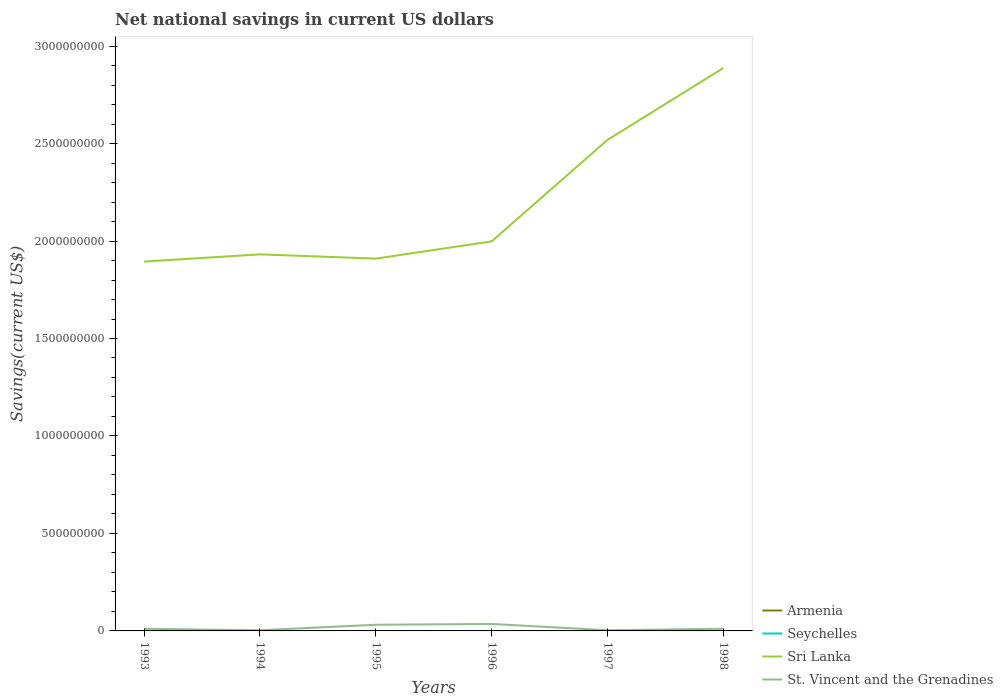What is the total net national savings in St. Vincent and the Grenadines in the graph?
Your answer should be very brief. -7.88e+06. What is the difference between the highest and the second highest net national savings in St. Vincent and the Grenadines?
Your response must be concise. 3.24e+07. Is the net national savings in Seychelles strictly greater than the net national savings in St. Vincent and the Grenadines over the years?
Your response must be concise. Yes. How many lines are there?
Your answer should be compact. 2. How many years are there in the graph?
Keep it short and to the point. 6. Does the graph contain any zero values?
Your answer should be compact. Yes. Does the graph contain grids?
Give a very brief answer. No. Where does the legend appear in the graph?
Provide a short and direct response. Bottom right. How are the legend labels stacked?
Offer a very short reply. Vertical. What is the title of the graph?
Provide a short and direct response. Net national savings in current US dollars. Does "St. Lucia" appear as one of the legend labels in the graph?
Give a very brief answer. No. What is the label or title of the Y-axis?
Your answer should be compact. Savings(current US$). What is the Savings(current US$) in Armenia in 1993?
Keep it short and to the point. 0. What is the Savings(current US$) in Sri Lanka in 1993?
Make the answer very short. 1.89e+09. What is the Savings(current US$) of St. Vincent and the Grenadines in 1993?
Make the answer very short. 1.11e+07. What is the Savings(current US$) in Sri Lanka in 1994?
Make the answer very short. 1.93e+09. What is the Savings(current US$) in St. Vincent and the Grenadines in 1994?
Ensure brevity in your answer.  3.37e+06. What is the Savings(current US$) in Sri Lanka in 1995?
Provide a succinct answer. 1.91e+09. What is the Savings(current US$) in St. Vincent and the Grenadines in 1995?
Provide a succinct answer. 3.17e+07. What is the Savings(current US$) in Seychelles in 1996?
Keep it short and to the point. 0. What is the Savings(current US$) of Sri Lanka in 1996?
Your response must be concise. 2.00e+09. What is the Savings(current US$) in St. Vincent and the Grenadines in 1996?
Provide a short and direct response. 3.58e+07. What is the Savings(current US$) in Sri Lanka in 1997?
Offer a terse response. 2.52e+09. What is the Savings(current US$) of St. Vincent and the Grenadines in 1997?
Your answer should be very brief. 3.52e+06. What is the Savings(current US$) in Seychelles in 1998?
Your answer should be very brief. 0. What is the Savings(current US$) in Sri Lanka in 1998?
Your response must be concise. 2.89e+09. What is the Savings(current US$) of St. Vincent and the Grenadines in 1998?
Make the answer very short. 1.14e+07. Across all years, what is the maximum Savings(current US$) of Sri Lanka?
Your answer should be very brief. 2.89e+09. Across all years, what is the maximum Savings(current US$) in St. Vincent and the Grenadines?
Provide a succinct answer. 3.58e+07. Across all years, what is the minimum Savings(current US$) in Sri Lanka?
Provide a succinct answer. 1.89e+09. Across all years, what is the minimum Savings(current US$) in St. Vincent and the Grenadines?
Give a very brief answer. 3.37e+06. What is the total Savings(current US$) in Sri Lanka in the graph?
Your response must be concise. 1.31e+1. What is the total Savings(current US$) in St. Vincent and the Grenadines in the graph?
Offer a terse response. 9.69e+07. What is the difference between the Savings(current US$) in Sri Lanka in 1993 and that in 1994?
Make the answer very short. -3.71e+07. What is the difference between the Savings(current US$) of St. Vincent and the Grenadines in 1993 and that in 1994?
Offer a terse response. 7.76e+06. What is the difference between the Savings(current US$) in Sri Lanka in 1993 and that in 1995?
Give a very brief answer. -1.53e+07. What is the difference between the Savings(current US$) in St. Vincent and the Grenadines in 1993 and that in 1995?
Keep it short and to the point. -2.05e+07. What is the difference between the Savings(current US$) in Sri Lanka in 1993 and that in 1996?
Offer a terse response. -1.04e+08. What is the difference between the Savings(current US$) of St. Vincent and the Grenadines in 1993 and that in 1996?
Give a very brief answer. -2.46e+07. What is the difference between the Savings(current US$) of Sri Lanka in 1993 and that in 1997?
Give a very brief answer. -6.24e+08. What is the difference between the Savings(current US$) of St. Vincent and the Grenadines in 1993 and that in 1997?
Give a very brief answer. 7.60e+06. What is the difference between the Savings(current US$) in Sri Lanka in 1993 and that in 1998?
Make the answer very short. -9.93e+08. What is the difference between the Savings(current US$) of St. Vincent and the Grenadines in 1993 and that in 1998?
Provide a short and direct response. -2.82e+05. What is the difference between the Savings(current US$) of Sri Lanka in 1994 and that in 1995?
Give a very brief answer. 2.18e+07. What is the difference between the Savings(current US$) in St. Vincent and the Grenadines in 1994 and that in 1995?
Ensure brevity in your answer.  -2.83e+07. What is the difference between the Savings(current US$) in Sri Lanka in 1994 and that in 1996?
Provide a succinct answer. -6.67e+07. What is the difference between the Savings(current US$) of St. Vincent and the Grenadines in 1994 and that in 1996?
Offer a very short reply. -3.24e+07. What is the difference between the Savings(current US$) of Sri Lanka in 1994 and that in 1997?
Ensure brevity in your answer.  -5.87e+08. What is the difference between the Savings(current US$) of St. Vincent and the Grenadines in 1994 and that in 1997?
Give a very brief answer. -1.56e+05. What is the difference between the Savings(current US$) of Sri Lanka in 1994 and that in 1998?
Give a very brief answer. -9.56e+08. What is the difference between the Savings(current US$) of St. Vincent and the Grenadines in 1994 and that in 1998?
Your answer should be compact. -8.04e+06. What is the difference between the Savings(current US$) of Sri Lanka in 1995 and that in 1996?
Keep it short and to the point. -8.85e+07. What is the difference between the Savings(current US$) in St. Vincent and the Grenadines in 1995 and that in 1996?
Make the answer very short. -4.11e+06. What is the difference between the Savings(current US$) of Sri Lanka in 1995 and that in 1997?
Your answer should be very brief. -6.09e+08. What is the difference between the Savings(current US$) of St. Vincent and the Grenadines in 1995 and that in 1997?
Your answer should be very brief. 2.81e+07. What is the difference between the Savings(current US$) of Sri Lanka in 1995 and that in 1998?
Provide a short and direct response. -9.78e+08. What is the difference between the Savings(current US$) in St. Vincent and the Grenadines in 1995 and that in 1998?
Keep it short and to the point. 2.03e+07. What is the difference between the Savings(current US$) in Sri Lanka in 1996 and that in 1997?
Your answer should be compact. -5.21e+08. What is the difference between the Savings(current US$) in St. Vincent and the Grenadines in 1996 and that in 1997?
Provide a short and direct response. 3.22e+07. What is the difference between the Savings(current US$) of Sri Lanka in 1996 and that in 1998?
Offer a very short reply. -8.89e+08. What is the difference between the Savings(current US$) in St. Vincent and the Grenadines in 1996 and that in 1998?
Keep it short and to the point. 2.44e+07. What is the difference between the Savings(current US$) of Sri Lanka in 1997 and that in 1998?
Provide a short and direct response. -3.69e+08. What is the difference between the Savings(current US$) of St. Vincent and the Grenadines in 1997 and that in 1998?
Offer a terse response. -7.88e+06. What is the difference between the Savings(current US$) of Sri Lanka in 1993 and the Savings(current US$) of St. Vincent and the Grenadines in 1994?
Keep it short and to the point. 1.89e+09. What is the difference between the Savings(current US$) in Sri Lanka in 1993 and the Savings(current US$) in St. Vincent and the Grenadines in 1995?
Make the answer very short. 1.86e+09. What is the difference between the Savings(current US$) of Sri Lanka in 1993 and the Savings(current US$) of St. Vincent and the Grenadines in 1996?
Your answer should be very brief. 1.86e+09. What is the difference between the Savings(current US$) in Sri Lanka in 1993 and the Savings(current US$) in St. Vincent and the Grenadines in 1997?
Ensure brevity in your answer.  1.89e+09. What is the difference between the Savings(current US$) in Sri Lanka in 1993 and the Savings(current US$) in St. Vincent and the Grenadines in 1998?
Your answer should be very brief. 1.88e+09. What is the difference between the Savings(current US$) in Sri Lanka in 1994 and the Savings(current US$) in St. Vincent and the Grenadines in 1995?
Ensure brevity in your answer.  1.90e+09. What is the difference between the Savings(current US$) of Sri Lanka in 1994 and the Savings(current US$) of St. Vincent and the Grenadines in 1996?
Keep it short and to the point. 1.90e+09. What is the difference between the Savings(current US$) in Sri Lanka in 1994 and the Savings(current US$) in St. Vincent and the Grenadines in 1997?
Offer a very short reply. 1.93e+09. What is the difference between the Savings(current US$) of Sri Lanka in 1994 and the Savings(current US$) of St. Vincent and the Grenadines in 1998?
Provide a short and direct response. 1.92e+09. What is the difference between the Savings(current US$) in Sri Lanka in 1995 and the Savings(current US$) in St. Vincent and the Grenadines in 1996?
Provide a short and direct response. 1.87e+09. What is the difference between the Savings(current US$) in Sri Lanka in 1995 and the Savings(current US$) in St. Vincent and the Grenadines in 1997?
Offer a very short reply. 1.91e+09. What is the difference between the Savings(current US$) of Sri Lanka in 1995 and the Savings(current US$) of St. Vincent and the Grenadines in 1998?
Your answer should be compact. 1.90e+09. What is the difference between the Savings(current US$) in Sri Lanka in 1996 and the Savings(current US$) in St. Vincent and the Grenadines in 1997?
Your answer should be very brief. 1.99e+09. What is the difference between the Savings(current US$) of Sri Lanka in 1996 and the Savings(current US$) of St. Vincent and the Grenadines in 1998?
Ensure brevity in your answer.  1.99e+09. What is the difference between the Savings(current US$) in Sri Lanka in 1997 and the Savings(current US$) in St. Vincent and the Grenadines in 1998?
Give a very brief answer. 2.51e+09. What is the average Savings(current US$) of Seychelles per year?
Provide a succinct answer. 0. What is the average Savings(current US$) of Sri Lanka per year?
Provide a succinct answer. 2.19e+09. What is the average Savings(current US$) in St. Vincent and the Grenadines per year?
Ensure brevity in your answer.  1.61e+07. In the year 1993, what is the difference between the Savings(current US$) in Sri Lanka and Savings(current US$) in St. Vincent and the Grenadines?
Provide a short and direct response. 1.88e+09. In the year 1994, what is the difference between the Savings(current US$) of Sri Lanka and Savings(current US$) of St. Vincent and the Grenadines?
Offer a very short reply. 1.93e+09. In the year 1995, what is the difference between the Savings(current US$) of Sri Lanka and Savings(current US$) of St. Vincent and the Grenadines?
Provide a succinct answer. 1.88e+09. In the year 1996, what is the difference between the Savings(current US$) of Sri Lanka and Savings(current US$) of St. Vincent and the Grenadines?
Your response must be concise. 1.96e+09. In the year 1997, what is the difference between the Savings(current US$) in Sri Lanka and Savings(current US$) in St. Vincent and the Grenadines?
Keep it short and to the point. 2.52e+09. In the year 1998, what is the difference between the Savings(current US$) in Sri Lanka and Savings(current US$) in St. Vincent and the Grenadines?
Make the answer very short. 2.88e+09. What is the ratio of the Savings(current US$) in Sri Lanka in 1993 to that in 1994?
Your response must be concise. 0.98. What is the ratio of the Savings(current US$) in St. Vincent and the Grenadines in 1993 to that in 1994?
Provide a succinct answer. 3.3. What is the ratio of the Savings(current US$) of Sri Lanka in 1993 to that in 1995?
Ensure brevity in your answer.  0.99. What is the ratio of the Savings(current US$) of St. Vincent and the Grenadines in 1993 to that in 1995?
Provide a short and direct response. 0.35. What is the ratio of the Savings(current US$) in Sri Lanka in 1993 to that in 1996?
Your response must be concise. 0.95. What is the ratio of the Savings(current US$) of St. Vincent and the Grenadines in 1993 to that in 1996?
Provide a short and direct response. 0.31. What is the ratio of the Savings(current US$) in Sri Lanka in 1993 to that in 1997?
Your answer should be compact. 0.75. What is the ratio of the Savings(current US$) in St. Vincent and the Grenadines in 1993 to that in 1997?
Ensure brevity in your answer.  3.16. What is the ratio of the Savings(current US$) of Sri Lanka in 1993 to that in 1998?
Your response must be concise. 0.66. What is the ratio of the Savings(current US$) in St. Vincent and the Grenadines in 1993 to that in 1998?
Your answer should be very brief. 0.98. What is the ratio of the Savings(current US$) of Sri Lanka in 1994 to that in 1995?
Make the answer very short. 1.01. What is the ratio of the Savings(current US$) in St. Vincent and the Grenadines in 1994 to that in 1995?
Ensure brevity in your answer.  0.11. What is the ratio of the Savings(current US$) in Sri Lanka in 1994 to that in 1996?
Your answer should be compact. 0.97. What is the ratio of the Savings(current US$) of St. Vincent and the Grenadines in 1994 to that in 1996?
Your answer should be very brief. 0.09. What is the ratio of the Savings(current US$) in Sri Lanka in 1994 to that in 1997?
Provide a succinct answer. 0.77. What is the ratio of the Savings(current US$) in St. Vincent and the Grenadines in 1994 to that in 1997?
Offer a very short reply. 0.96. What is the ratio of the Savings(current US$) of Sri Lanka in 1994 to that in 1998?
Offer a very short reply. 0.67. What is the ratio of the Savings(current US$) in St. Vincent and the Grenadines in 1994 to that in 1998?
Give a very brief answer. 0.3. What is the ratio of the Savings(current US$) of Sri Lanka in 1995 to that in 1996?
Your answer should be very brief. 0.96. What is the ratio of the Savings(current US$) in St. Vincent and the Grenadines in 1995 to that in 1996?
Your answer should be compact. 0.89. What is the ratio of the Savings(current US$) in Sri Lanka in 1995 to that in 1997?
Keep it short and to the point. 0.76. What is the ratio of the Savings(current US$) of St. Vincent and the Grenadines in 1995 to that in 1997?
Your answer should be very brief. 8.98. What is the ratio of the Savings(current US$) of Sri Lanka in 1995 to that in 1998?
Ensure brevity in your answer.  0.66. What is the ratio of the Savings(current US$) in St. Vincent and the Grenadines in 1995 to that in 1998?
Offer a terse response. 2.78. What is the ratio of the Savings(current US$) of Sri Lanka in 1996 to that in 1997?
Ensure brevity in your answer.  0.79. What is the ratio of the Savings(current US$) in St. Vincent and the Grenadines in 1996 to that in 1997?
Ensure brevity in your answer.  10.15. What is the ratio of the Savings(current US$) of Sri Lanka in 1996 to that in 1998?
Your answer should be very brief. 0.69. What is the ratio of the Savings(current US$) in St. Vincent and the Grenadines in 1996 to that in 1998?
Offer a very short reply. 3.14. What is the ratio of the Savings(current US$) of Sri Lanka in 1997 to that in 1998?
Provide a short and direct response. 0.87. What is the ratio of the Savings(current US$) of St. Vincent and the Grenadines in 1997 to that in 1998?
Your answer should be very brief. 0.31. What is the difference between the highest and the second highest Savings(current US$) of Sri Lanka?
Make the answer very short. 3.69e+08. What is the difference between the highest and the second highest Savings(current US$) of St. Vincent and the Grenadines?
Ensure brevity in your answer.  4.11e+06. What is the difference between the highest and the lowest Savings(current US$) in Sri Lanka?
Ensure brevity in your answer.  9.93e+08. What is the difference between the highest and the lowest Savings(current US$) of St. Vincent and the Grenadines?
Offer a terse response. 3.24e+07. 